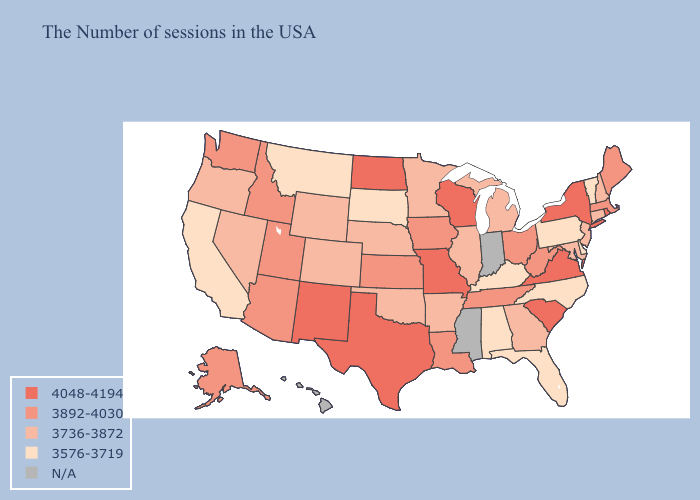Name the states that have a value in the range N/A?
Quick response, please. Indiana, Mississippi, Hawaii. Name the states that have a value in the range N/A?
Give a very brief answer. Indiana, Mississippi, Hawaii. What is the highest value in states that border Arkansas?
Answer briefly. 4048-4194. Among the states that border Massachusetts , does Rhode Island have the highest value?
Give a very brief answer. Yes. Name the states that have a value in the range 3576-3719?
Be succinct. Vermont, Delaware, Pennsylvania, North Carolina, Florida, Kentucky, Alabama, South Dakota, Montana, California. Name the states that have a value in the range 3576-3719?
Keep it brief. Vermont, Delaware, Pennsylvania, North Carolina, Florida, Kentucky, Alabama, South Dakota, Montana, California. Name the states that have a value in the range N/A?
Short answer required. Indiana, Mississippi, Hawaii. Name the states that have a value in the range 4048-4194?
Quick response, please. Rhode Island, New York, Virginia, South Carolina, Wisconsin, Missouri, Texas, North Dakota, New Mexico. What is the value of Montana?
Quick response, please. 3576-3719. Among the states that border Delaware , does New Jersey have the lowest value?
Concise answer only. No. Does Kansas have the lowest value in the MidWest?
Answer briefly. No. Which states have the highest value in the USA?
Quick response, please. Rhode Island, New York, Virginia, South Carolina, Wisconsin, Missouri, Texas, North Dakota, New Mexico. What is the value of Minnesota?
Be succinct. 3736-3872. Name the states that have a value in the range N/A?
Quick response, please. Indiana, Mississippi, Hawaii. 